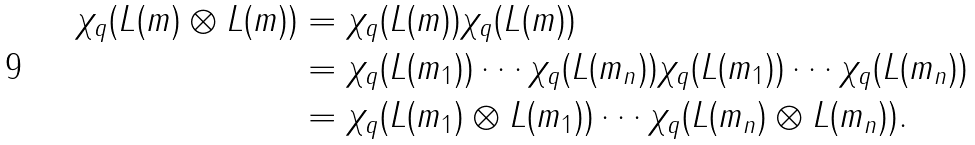Convert formula to latex. <formula><loc_0><loc_0><loc_500><loc_500>\chi _ { q } ( L ( m ) \otimes L ( m ) ) & = \chi _ { q } ( L ( m ) ) \chi _ { q } ( L ( m ) ) \\ & = \chi _ { q } ( L ( m _ { 1 } ) ) \cdots \chi _ { q } ( L ( m _ { n } ) ) \chi _ { q } ( L ( m _ { 1 } ) ) \cdots \chi _ { q } ( L ( m _ { n } ) ) \\ & = \chi _ { q } ( L ( m _ { 1 } ) \otimes L ( m _ { 1 } ) ) \cdots \chi _ { q } ( L ( m _ { n } ) \otimes L ( m _ { n } ) ) .</formula> 